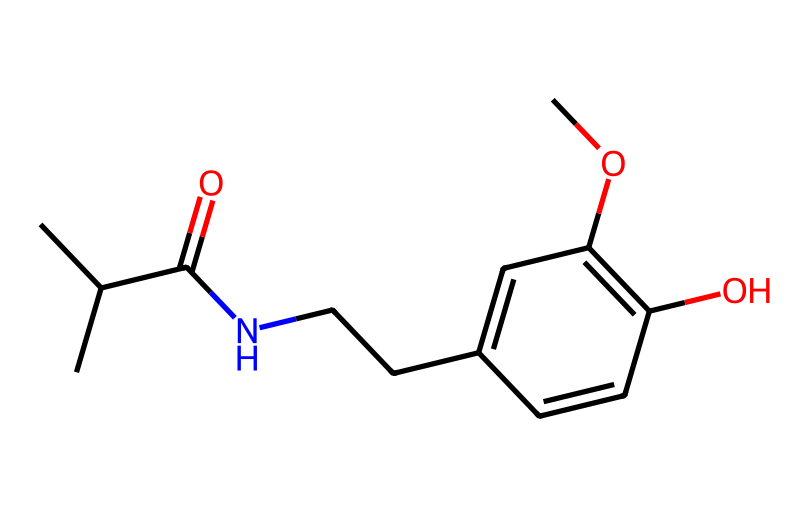What is the overall molecular formula of this compound? To determine the molecular formula, we count the number of each type of atom in the SMILES string: there are 14 carbon (C), 19 hydrogen (H), 1 nitrogen (N), and 3 oxygen (O) atoms. Therefore, the overall formula is C14H19N3O3.
Answer: C14H19N3O3 How many carbon atoms are present in this chemical structure? By analyzing the SMILES representation, each "C" signifies a carbon atom. Counting all "C" instances and groups (including those in branches), we find 14 carbon atoms.
Answer: 14 What functional groups can be identified in this compound? Looking at the structure indicated by the SMILES line, we identify several functional groups: there is an amide (due to the presence of C(=O)N), hydroxyl (–OH), and ether (–O–). The presence of these groups indicates diverse chemical properties.
Answer: amide, hydroxyl, ether Is this compound primarily hydrophilic or hydrophobic? The presence of polar functional groups (like –OH and –O–) suggests that this compound is hydrophilic, as these groups can engage in hydrogen bonding with water, enhancing solubility.
Answer: hydrophilic What role does the nitrogen atom play in the structure of this alkaloid? Nitrogen atoms are characteristic of alkaloids, and in this structure, the nitrogen participates in creating an amide group, which is crucial for the biological activity and properties such as pain relief associated with capsaicin.
Answer: amide group How does the presence of the hydroxyl group affect the properties of capsaicin? The hydroxyl group (–OH) can interact with water due to its polarity, potentially enhancing the solubility of the compound in aqueous solutions while also influencing the spicy flavor profile and sensory properties.
Answer: increases solubility What is the significance of the double bond in this alkaloid structure? The presence of double bonds can indicate potential reactivity and stability within the molecule. Double bonds can also affect the rigidity and shape of the chemical, which plays a crucial role in the interaction of capsaicin with receptors to produce a spicy sensation.
Answer: reactivity and shape 